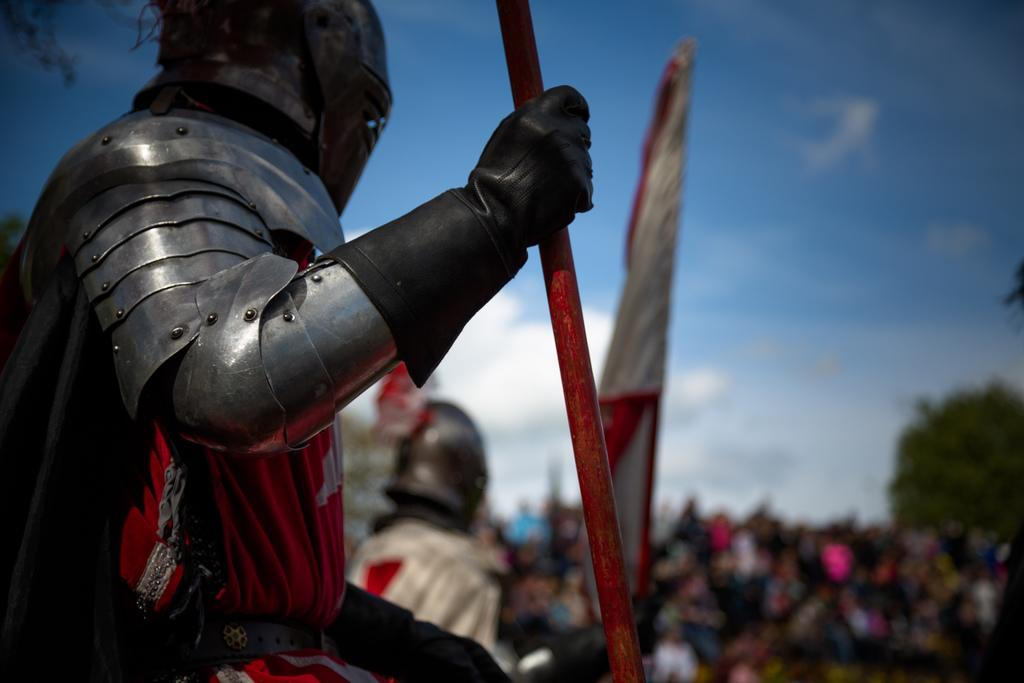How many people are in the image? There are people in the image, but the exact number is not specified. What are the people holding in the image? One person is holding a rod, and another person is holding a flag. What can be seen in the background of the image? There is a tree and the sky visible in the background of the image. What type of yoke is being used by the people in the image? There is no yoke present in the image. What government policy is being discussed by the people in the image? There is no indication of any government policy or discussion in the image. 